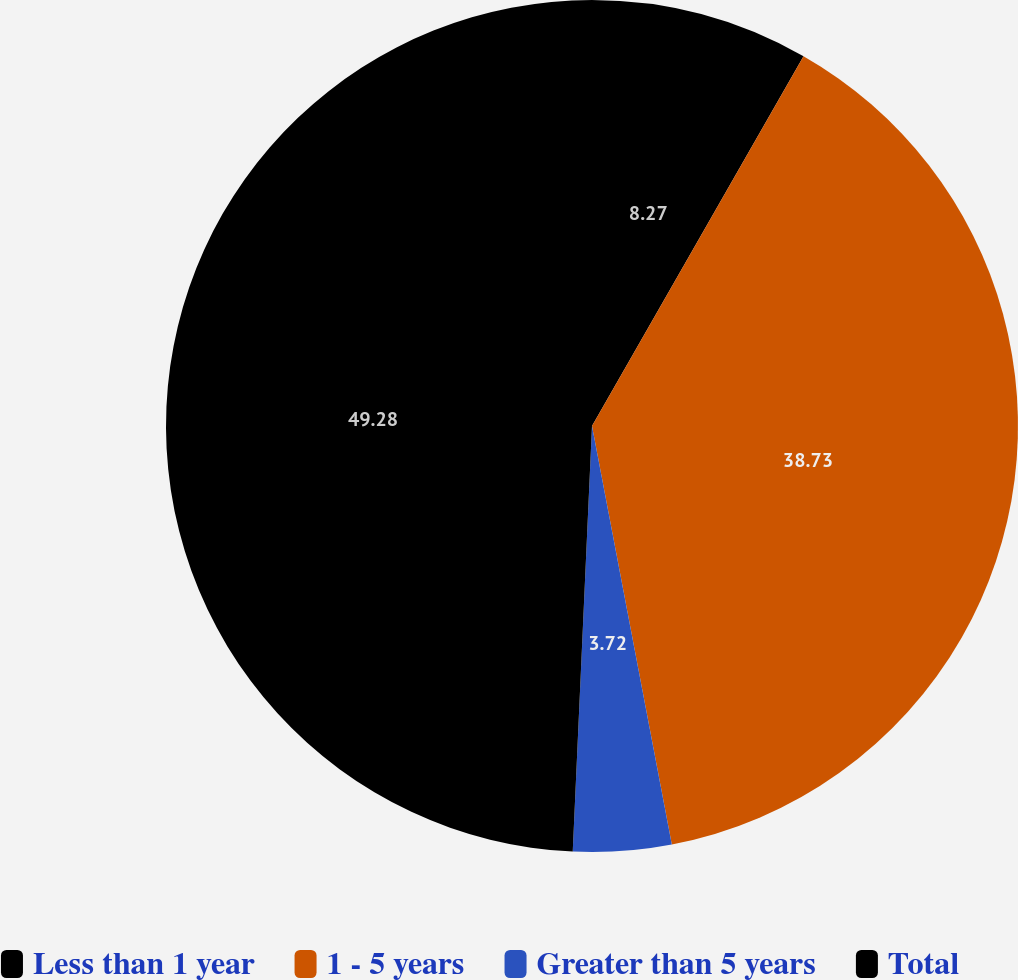Convert chart to OTSL. <chart><loc_0><loc_0><loc_500><loc_500><pie_chart><fcel>Less than 1 year<fcel>1 - 5 years<fcel>Greater than 5 years<fcel>Total<nl><fcel>8.27%<fcel>38.73%<fcel>3.72%<fcel>49.28%<nl></chart> 